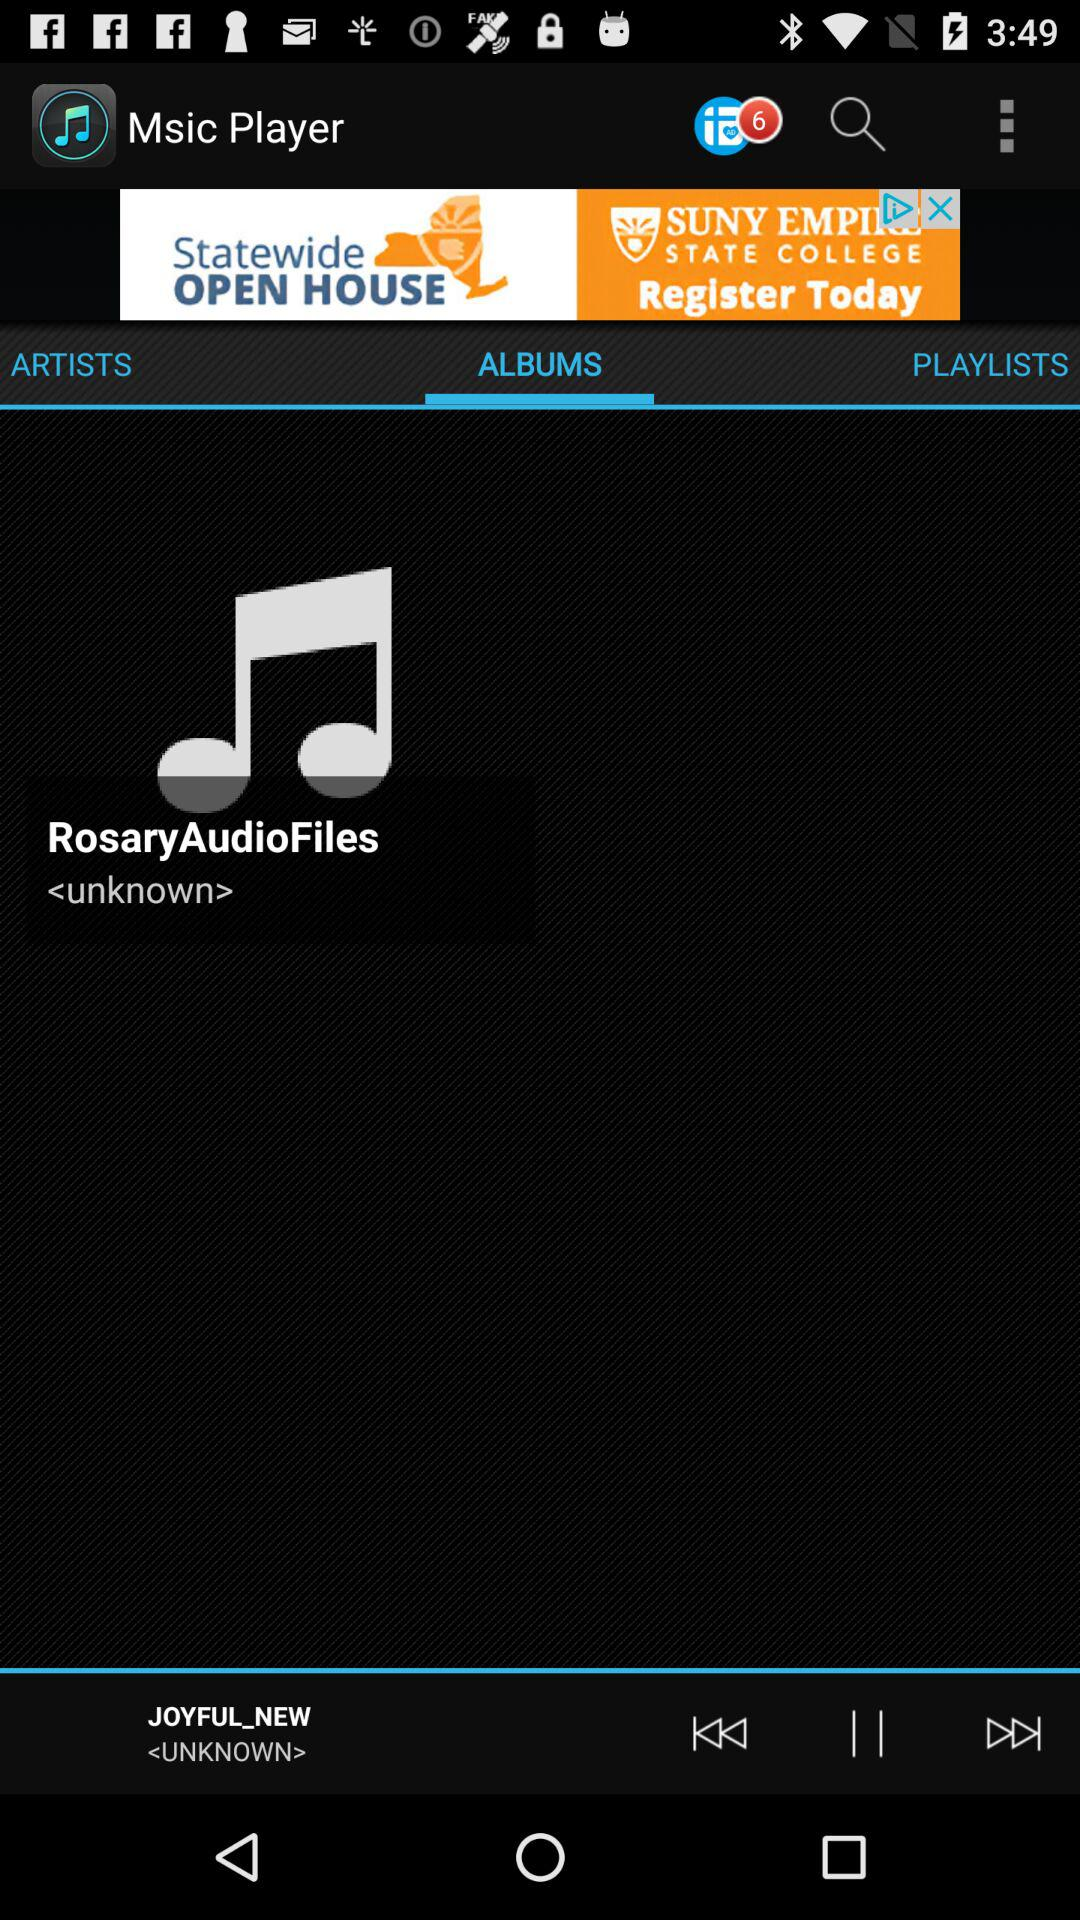Which option is selected? The selected option is "ALBUMS". 